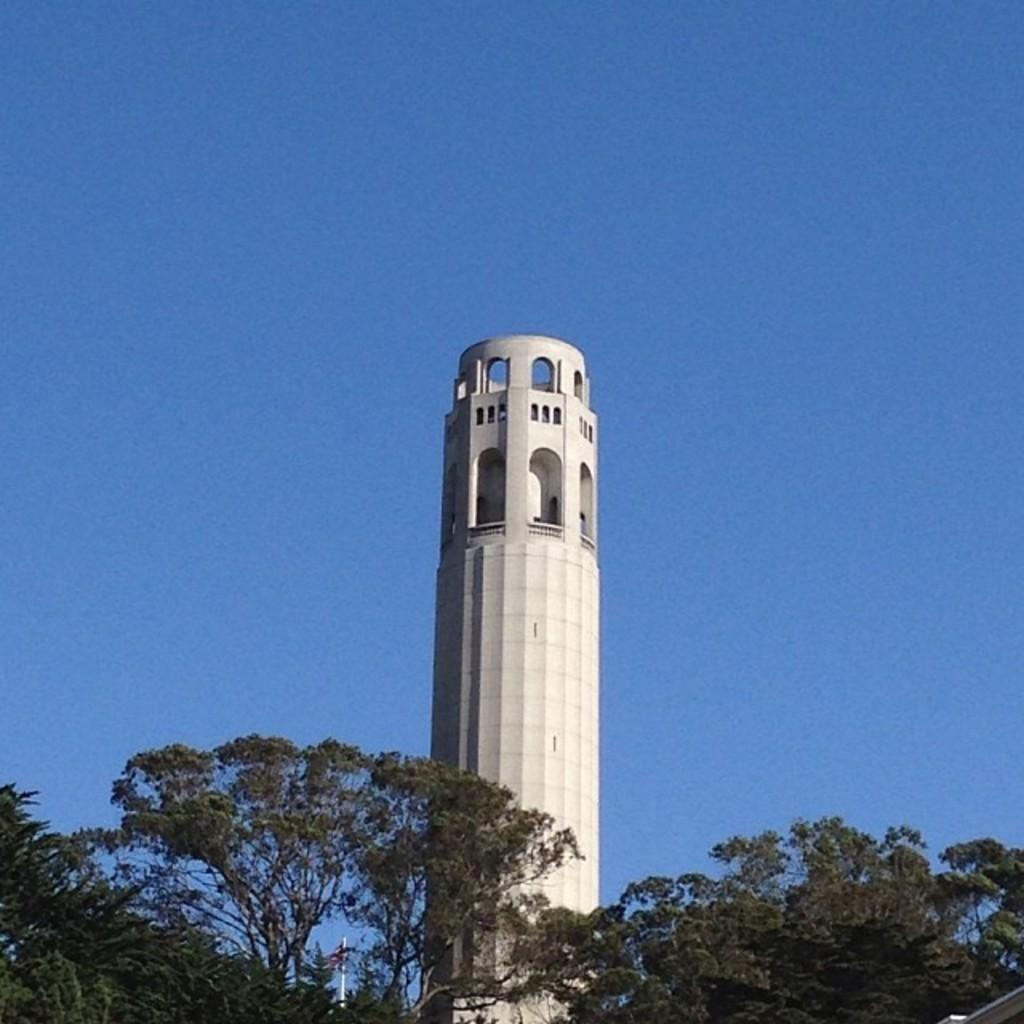What can be seen in the background of the image? There is a sky visible in the image. What type of vegetation is present in the image? There are trees in the image. What structure is located in the center of the image? There is a tower in the center of the image. What type of chain is hanging from the tower in the image? There is no chain hanging from the tower in the image; only the tower itself is present. What type of plant is growing on the trees in the image? The provided facts do not mention any specific type of plant growing on the trees; only the presence of trees is mentioned. 